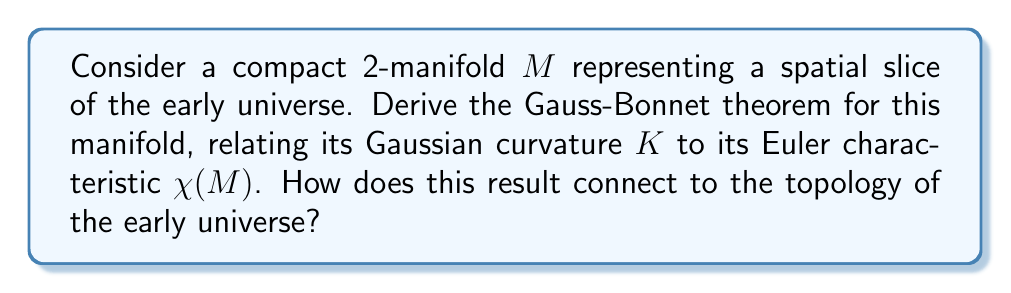Solve this math problem. 1. Start with the Gauss-Bonnet theorem for a compact 2-manifold $M$:

   $$\int_M K dA = 2\pi\chi(M)$$

   where $K$ is the Gaussian curvature and $dA$ is the area element.

2. For a spatial slice of the early universe, we can assume the manifold is orientable and without boundary. The Euler characteristic $\chi(M)$ is given by:

   $$\chi(M) = 2 - 2g$$

   where $g$ is the genus of the manifold.

3. Substitute this into the Gauss-Bonnet theorem:

   $$\int_M K dA = 2\pi(2 - 2g)$$

4. The left-hand side represents the total Gaussian curvature of the manifold. In the context of the early universe, this curvature is related to the energy density distribution.

5. The right-hand side is determined by the topology of the manifold. Different values of $g$ correspond to different topological structures of the universe:

   - $g = 0$: Spherical topology (positive curvature)
   - $g = 1$: Toroidal topology (flat curvature)
   - $g > 1$: Higher genus topology (negative curvature)

6. This result connects the geometry (curvature) of the early universe to its topology. The cosmic microwave background radiation can provide observational constraints on the curvature, which in turn informs us about the possible topological structures of the universe.

7. The formula also implies that the total curvature of a closed universe is quantized in units of $4\pi$, which could have implications for quantum cosmology models.
Answer: $\int_M K dA = 4\pi(1 - g)$, where $g$ is the genus of the manifold. 